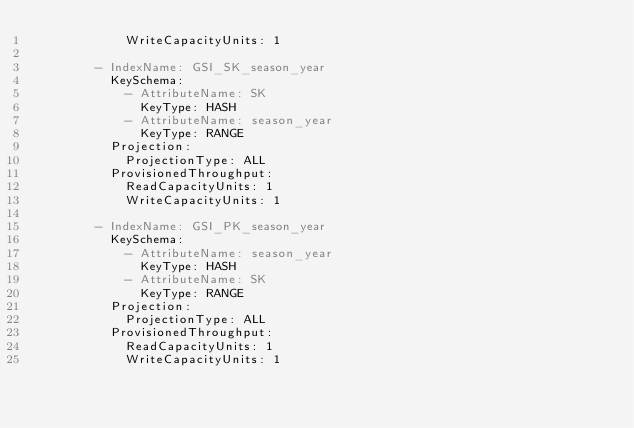Convert code to text. <code><loc_0><loc_0><loc_500><loc_500><_YAML_>            WriteCapacityUnits: 1

        - IndexName: GSI_SK_season_year
          KeySchema:
            - AttributeName: SK
              KeyType: HASH
            - AttributeName: season_year
              KeyType: RANGE
          Projection:
            ProjectionType: ALL
          ProvisionedThroughput:
            ReadCapacityUnits: 1
            WriteCapacityUnits: 1

        - IndexName: GSI_PK_season_year
          KeySchema:
            - AttributeName: season_year
              KeyType: HASH
            - AttributeName: SK
              KeyType: RANGE
          Projection:
            ProjectionType: ALL
          ProvisionedThroughput:
            ReadCapacityUnits: 1
            WriteCapacityUnits: 1
</code> 